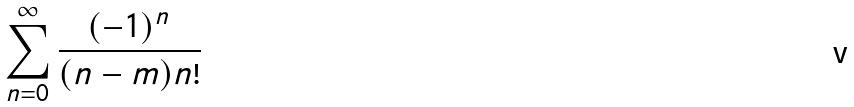Convert formula to latex. <formula><loc_0><loc_0><loc_500><loc_500>\sum _ { n = 0 } ^ { \infty } \frac { ( - 1 ) ^ { n } } { ( n - m ) n ! }</formula> 